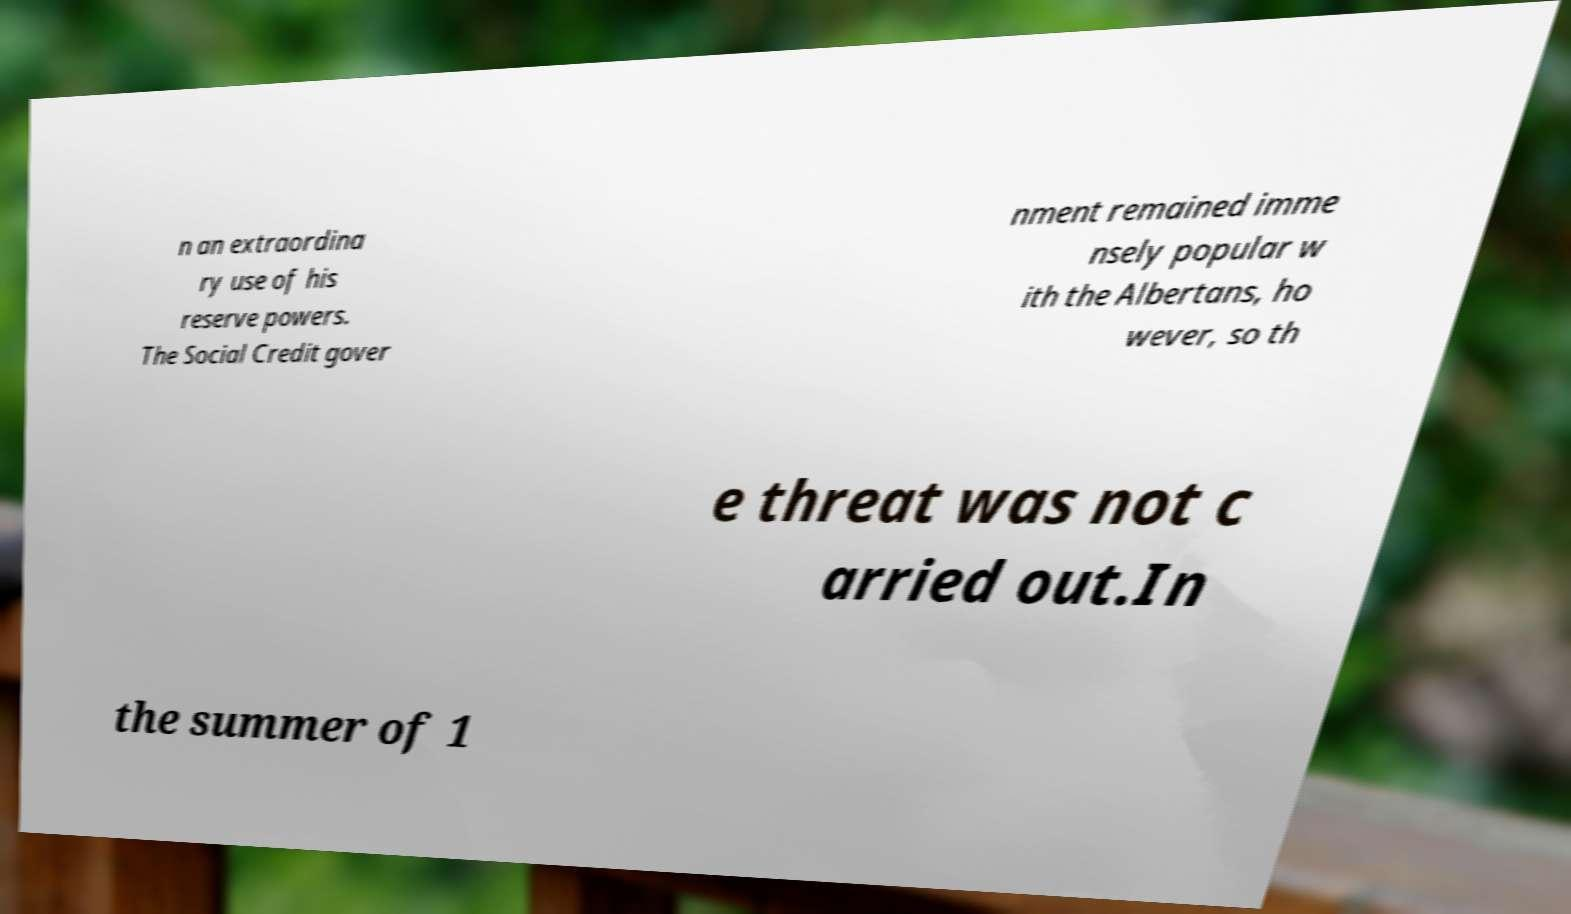There's text embedded in this image that I need extracted. Can you transcribe it verbatim? n an extraordina ry use of his reserve powers. The Social Credit gover nment remained imme nsely popular w ith the Albertans, ho wever, so th e threat was not c arried out.In the summer of 1 